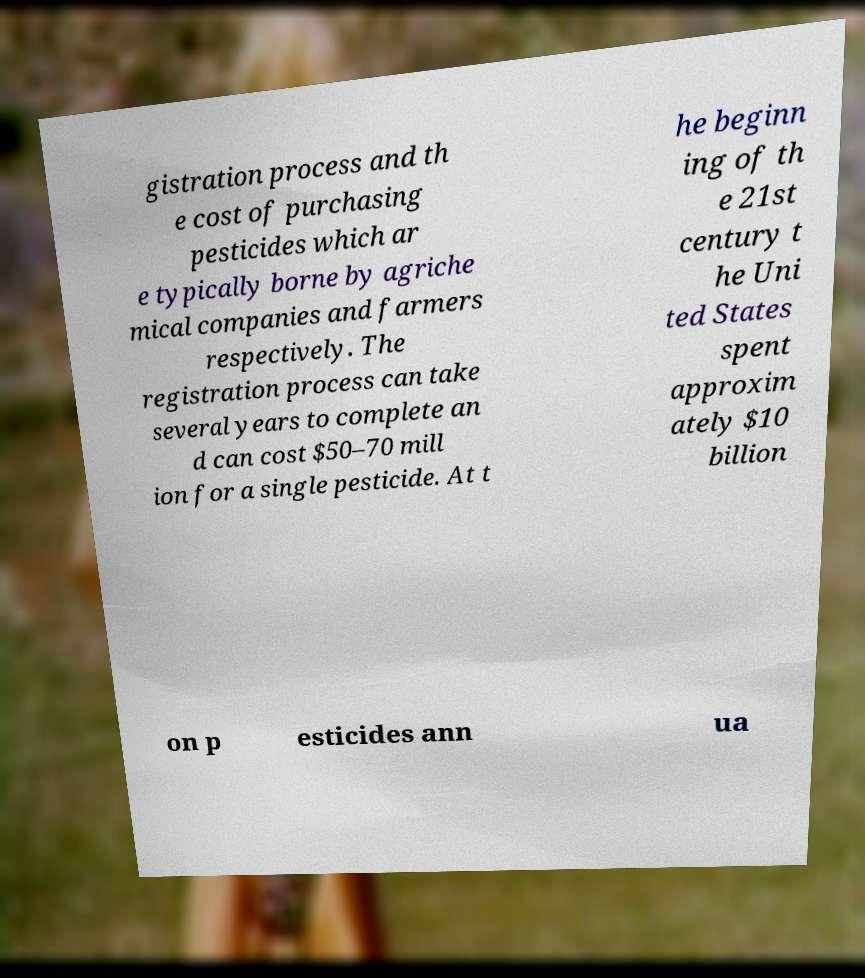Could you assist in decoding the text presented in this image and type it out clearly? gistration process and th e cost of purchasing pesticides which ar e typically borne by agriche mical companies and farmers respectively. The registration process can take several years to complete an d can cost $50–70 mill ion for a single pesticide. At t he beginn ing of th e 21st century t he Uni ted States spent approxim ately $10 billion on p esticides ann ua 